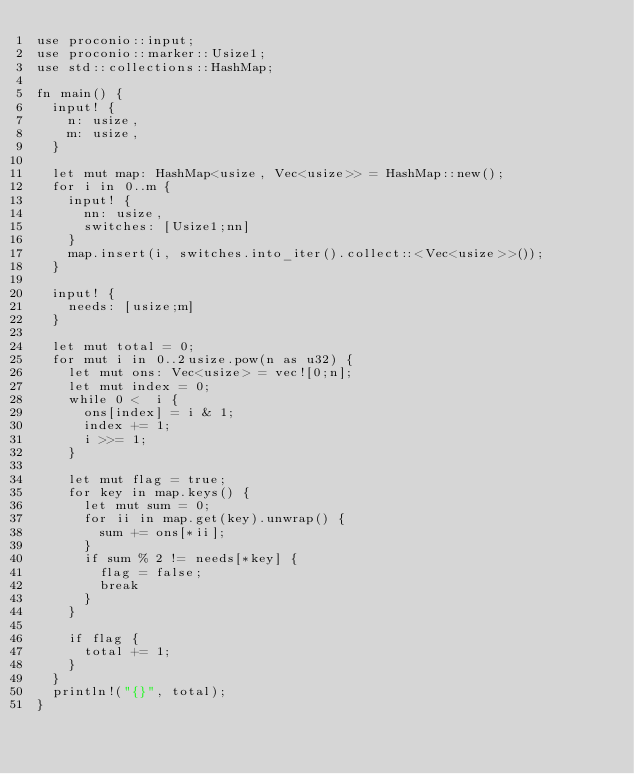Convert code to text. <code><loc_0><loc_0><loc_500><loc_500><_Rust_>use proconio::input;
use proconio::marker::Usize1;
use std::collections::HashMap;

fn main() {
  input! {
    n: usize,
    m: usize,
  }
  
  let mut map: HashMap<usize, Vec<usize>> = HashMap::new();
  for i in 0..m {
    input! {
      nn: usize,
      switches: [Usize1;nn]
    }
    map.insert(i, switches.into_iter().collect::<Vec<usize>>());
  }
  
  input! {
    needs: [usize;m]
  }
  
  let mut total = 0;
  for mut i in 0..2usize.pow(n as u32) {
    let mut ons: Vec<usize> = vec![0;n];
    let mut index = 0;
    while 0 <  i {
      ons[index] = i & 1;
      index += 1;
      i >>= 1;
    }
    
    let mut flag = true;
    for key in map.keys() {
      let mut sum = 0;
      for ii in map.get(key).unwrap() {
        sum += ons[*ii];
      }
      if sum % 2 != needs[*key] {
        flag = false;
        break
      }
    }
    
    if flag {
      total += 1;
    }
  }
  println!("{}", total);  
}</code> 